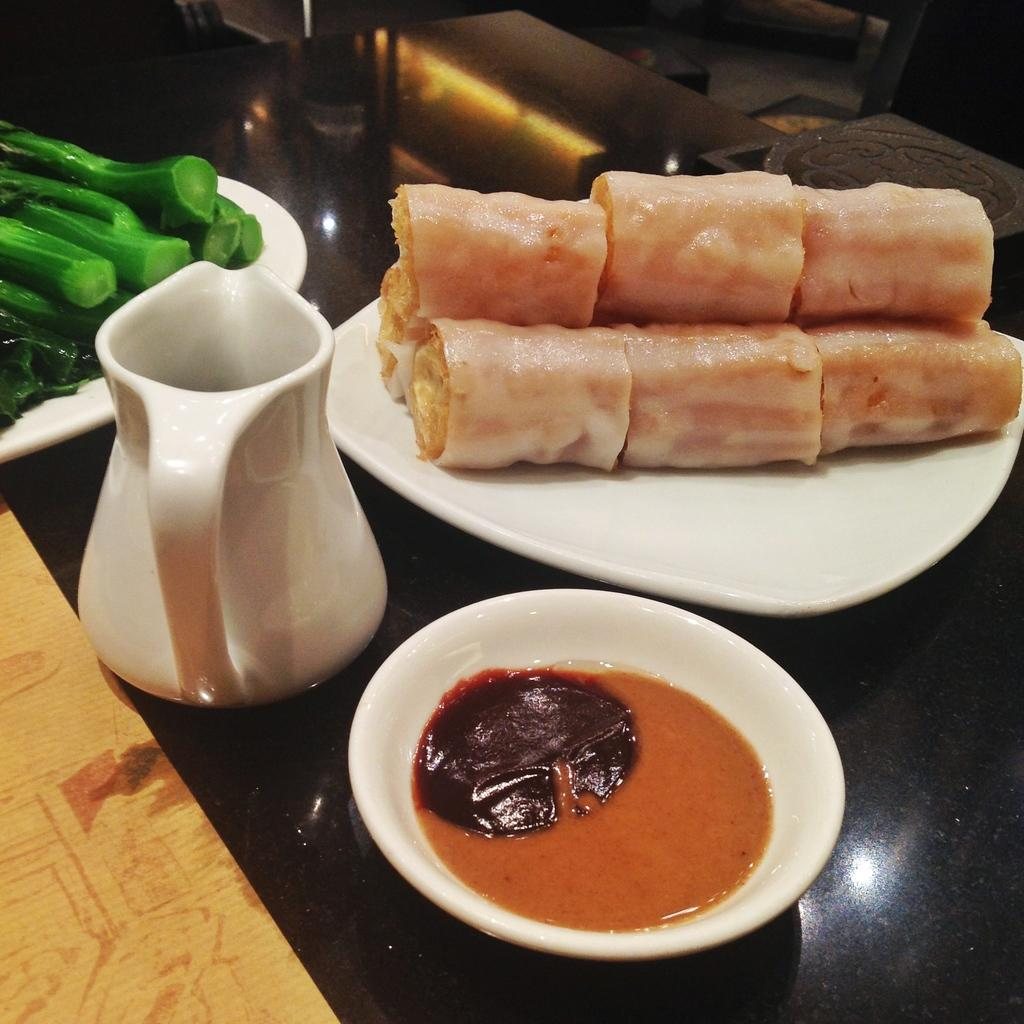What is on the plate that is visible in the image? There is a plate with food items in the image. What is in the bowl that is visible in the image? There is a bowl with sauce in the image. What type of container is present in the image? There is a jar in the image. Are there any other plates with food items in the image? Yes, there is another plate with food items in the image. What is the color of the surface beneath the second plate? The surface beneath the second plate is black. Can you tell me how many times the jar shakes in the image? There is no indication of the jar shaking in the image; it is stationary. What type of bread is present on the side of the plate? There is no bread present on the plate or in the image. 